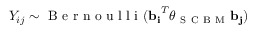Convert formula to latex. <formula><loc_0><loc_0><loc_500><loc_500>{ Y _ { i j } \sim B e r n o u l l i ( \mathbf { b } _ { i } ^ { T } \theta _ { S C B M } b _ { j } ) }</formula> 